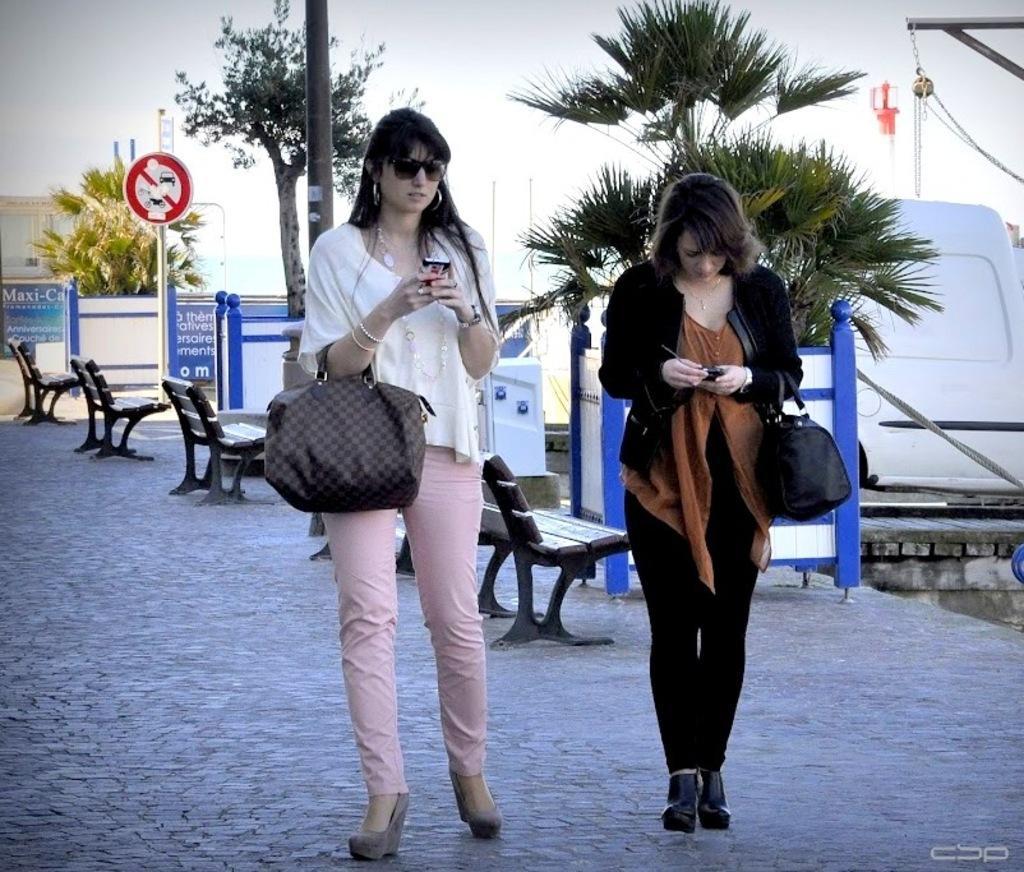How would you summarize this image in a sentence or two? In this image i can see the women walking, the woman at left wearing a white shirt and a pink pant holding a black bag a woman at right wearing a brown shirt and black pant wearing a black bag, at the background there few benches, a blue color boards, a tree and a sky. 